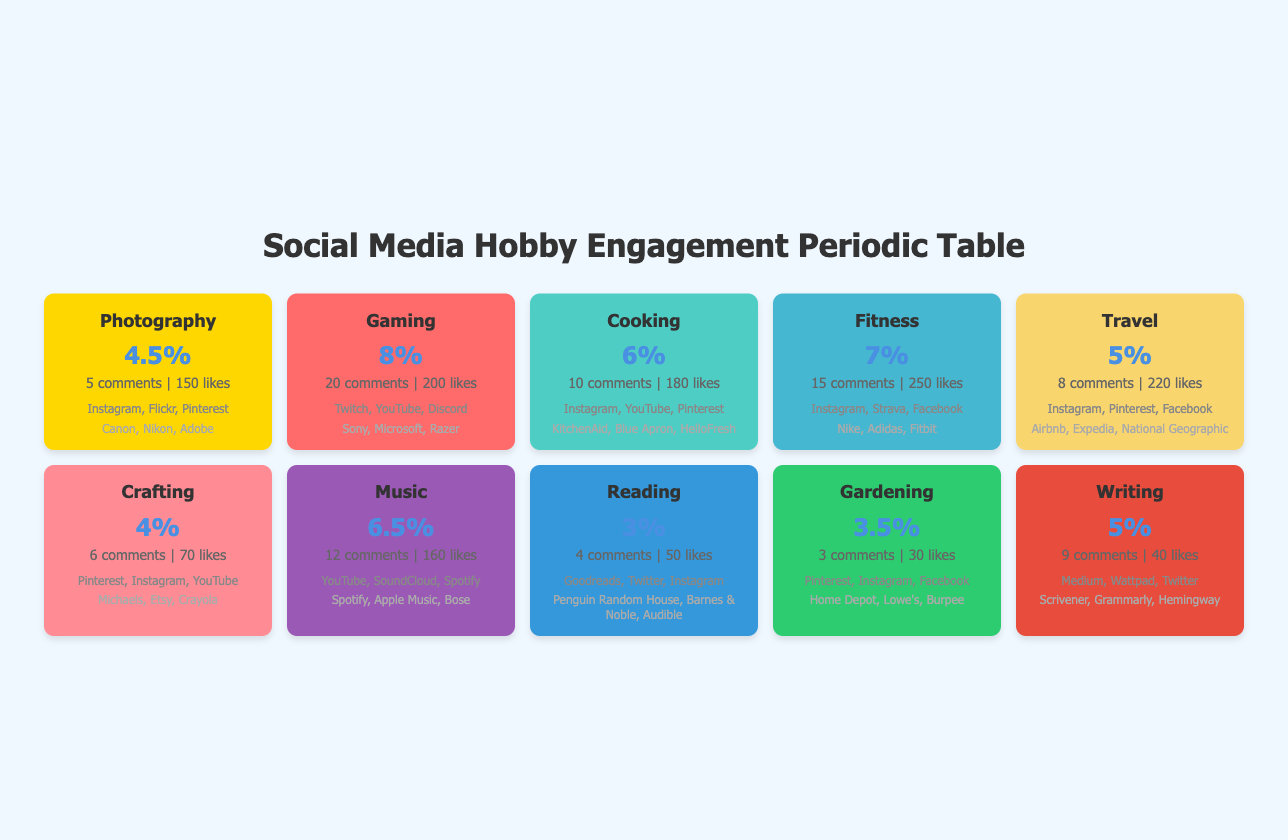What is the highest average engagement rate among the hobbies? By examining the table, "Gaming" has an engagement rate of 0.08, which is the highest when compared to all other categories listed.
Answer: 0.08 Which hobby category has the most comments per post? Looking at the comments per post, "Gaming" has 20 comments, which is higher than any other category in the table.
Answer: Gaming How many likes do posts in the "Fitness" category receive on average? The table shows that the average likes per post for "Fitness" is 250.
Answer: 250 Is the average engagement rate for "Cooking" higher than that for "Travel"? The engagement rate for "Cooking" is 0.06, while for "Travel" it is 0.05. Since 0.06 is greater than 0.05, the statement is true.
Answer: Yes What is the average number of likes per post across all hobby categories? To find the average, sum the likes per post (150 + 200 + 180 + 250 + 220 + 70 + 160 + 50 + 30 + 40 = 1400), then divide by the number of categories (10). The average is 1400 / 10 = 140.
Answer: 140 Which hobby category has the least amount of average likes per post? Comparing the average likes per post, "Gardening" has the lowest at 30 likes.
Answer: Gardening Do "Music" and "Fitness" have the same average number of comments per post? "Music" has 12 comments while "Fitness" has 15 comments. Since these numbers are not equal, the statement is false.
Answer: No What is the combined total of average comments per post for "Photography" and "Crafting"? The average comments for "Photography" is 5 and for "Crafting" is 6. Adding these gives (5 + 6 = 11).
Answer: 11 Which popular platform is shared between "Cooking" and "Photography"? Both "Cooking" and "Photography" list "Instagram" as one of their popular platforms.
Answer: Instagram 